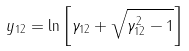Convert formula to latex. <formula><loc_0><loc_0><loc_500><loc_500>y _ { 1 2 } = \ln \left [ \gamma _ { 1 2 } + \sqrt { \gamma _ { 1 2 } ^ { 2 } - 1 } \right ]</formula> 